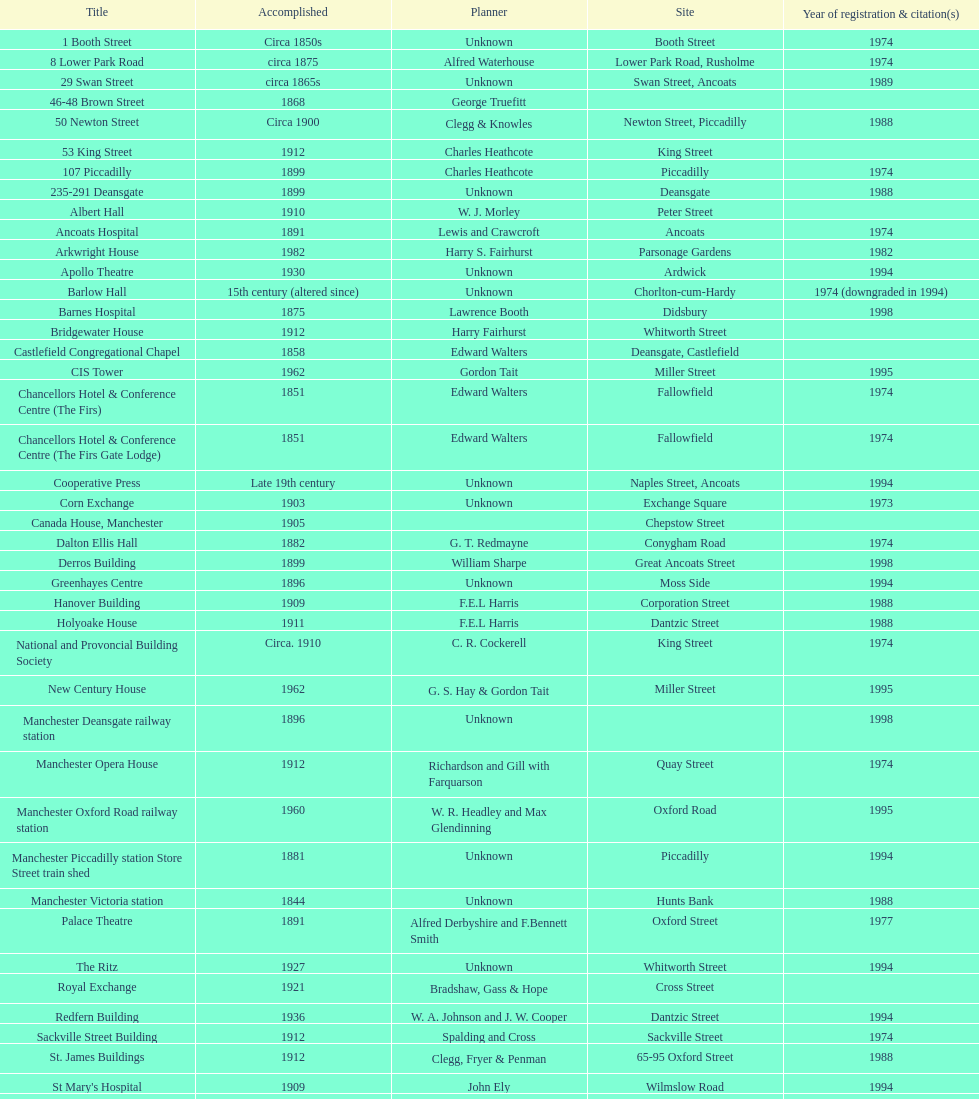How many constructions share the same year of listing as 1974? 15. 